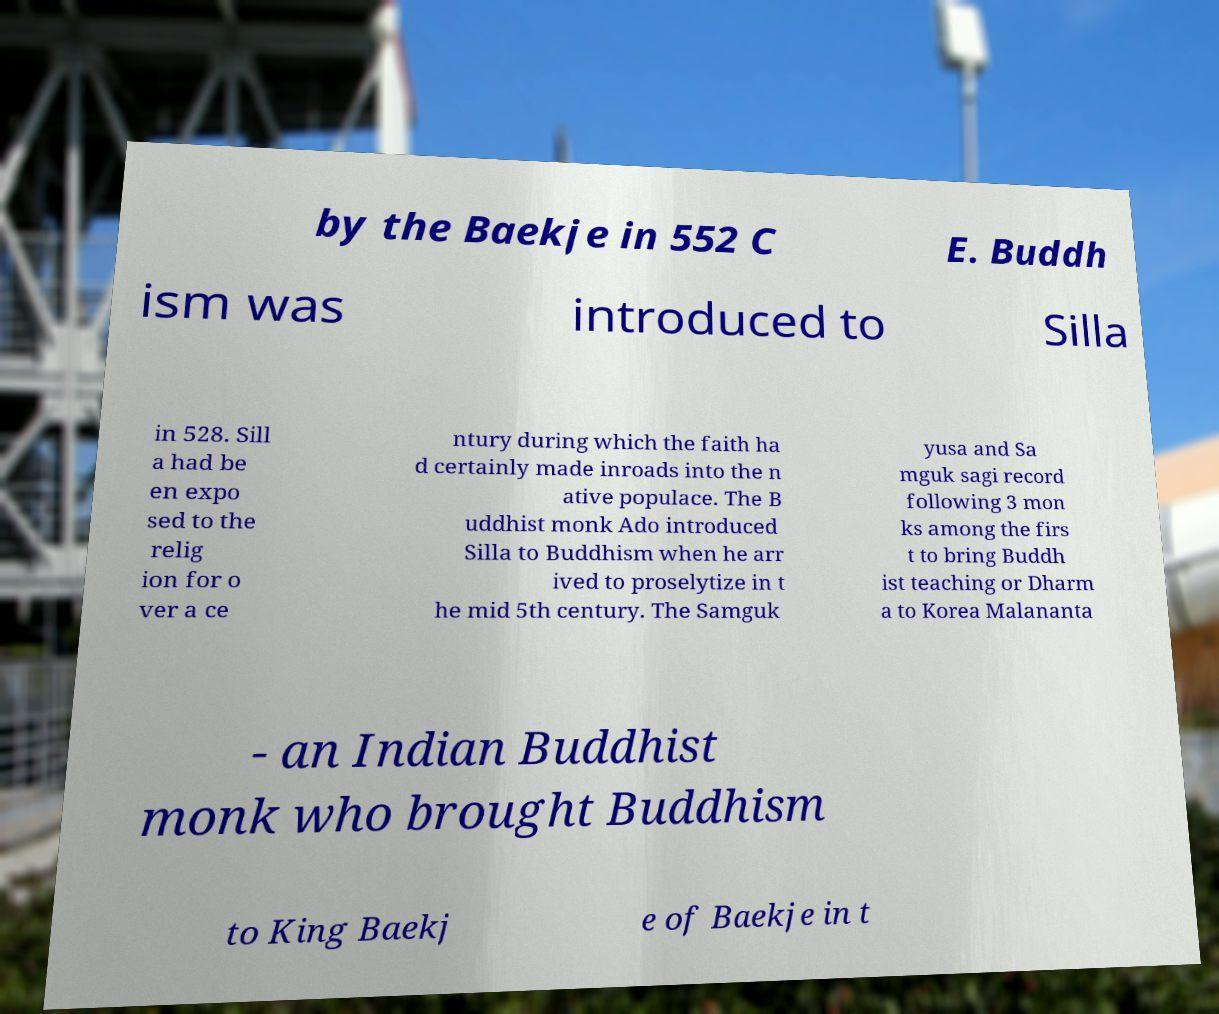Can you accurately transcribe the text from the provided image for me? by the Baekje in 552 C E. Buddh ism was introduced to Silla in 528. Sill a had be en expo sed to the relig ion for o ver a ce ntury during which the faith ha d certainly made inroads into the n ative populace. The B uddhist monk Ado introduced Silla to Buddhism when he arr ived to proselytize in t he mid 5th century. The Samguk yusa and Sa mguk sagi record following 3 mon ks among the firs t to bring Buddh ist teaching or Dharm a to Korea Malananta - an Indian Buddhist monk who brought Buddhism to King Baekj e of Baekje in t 